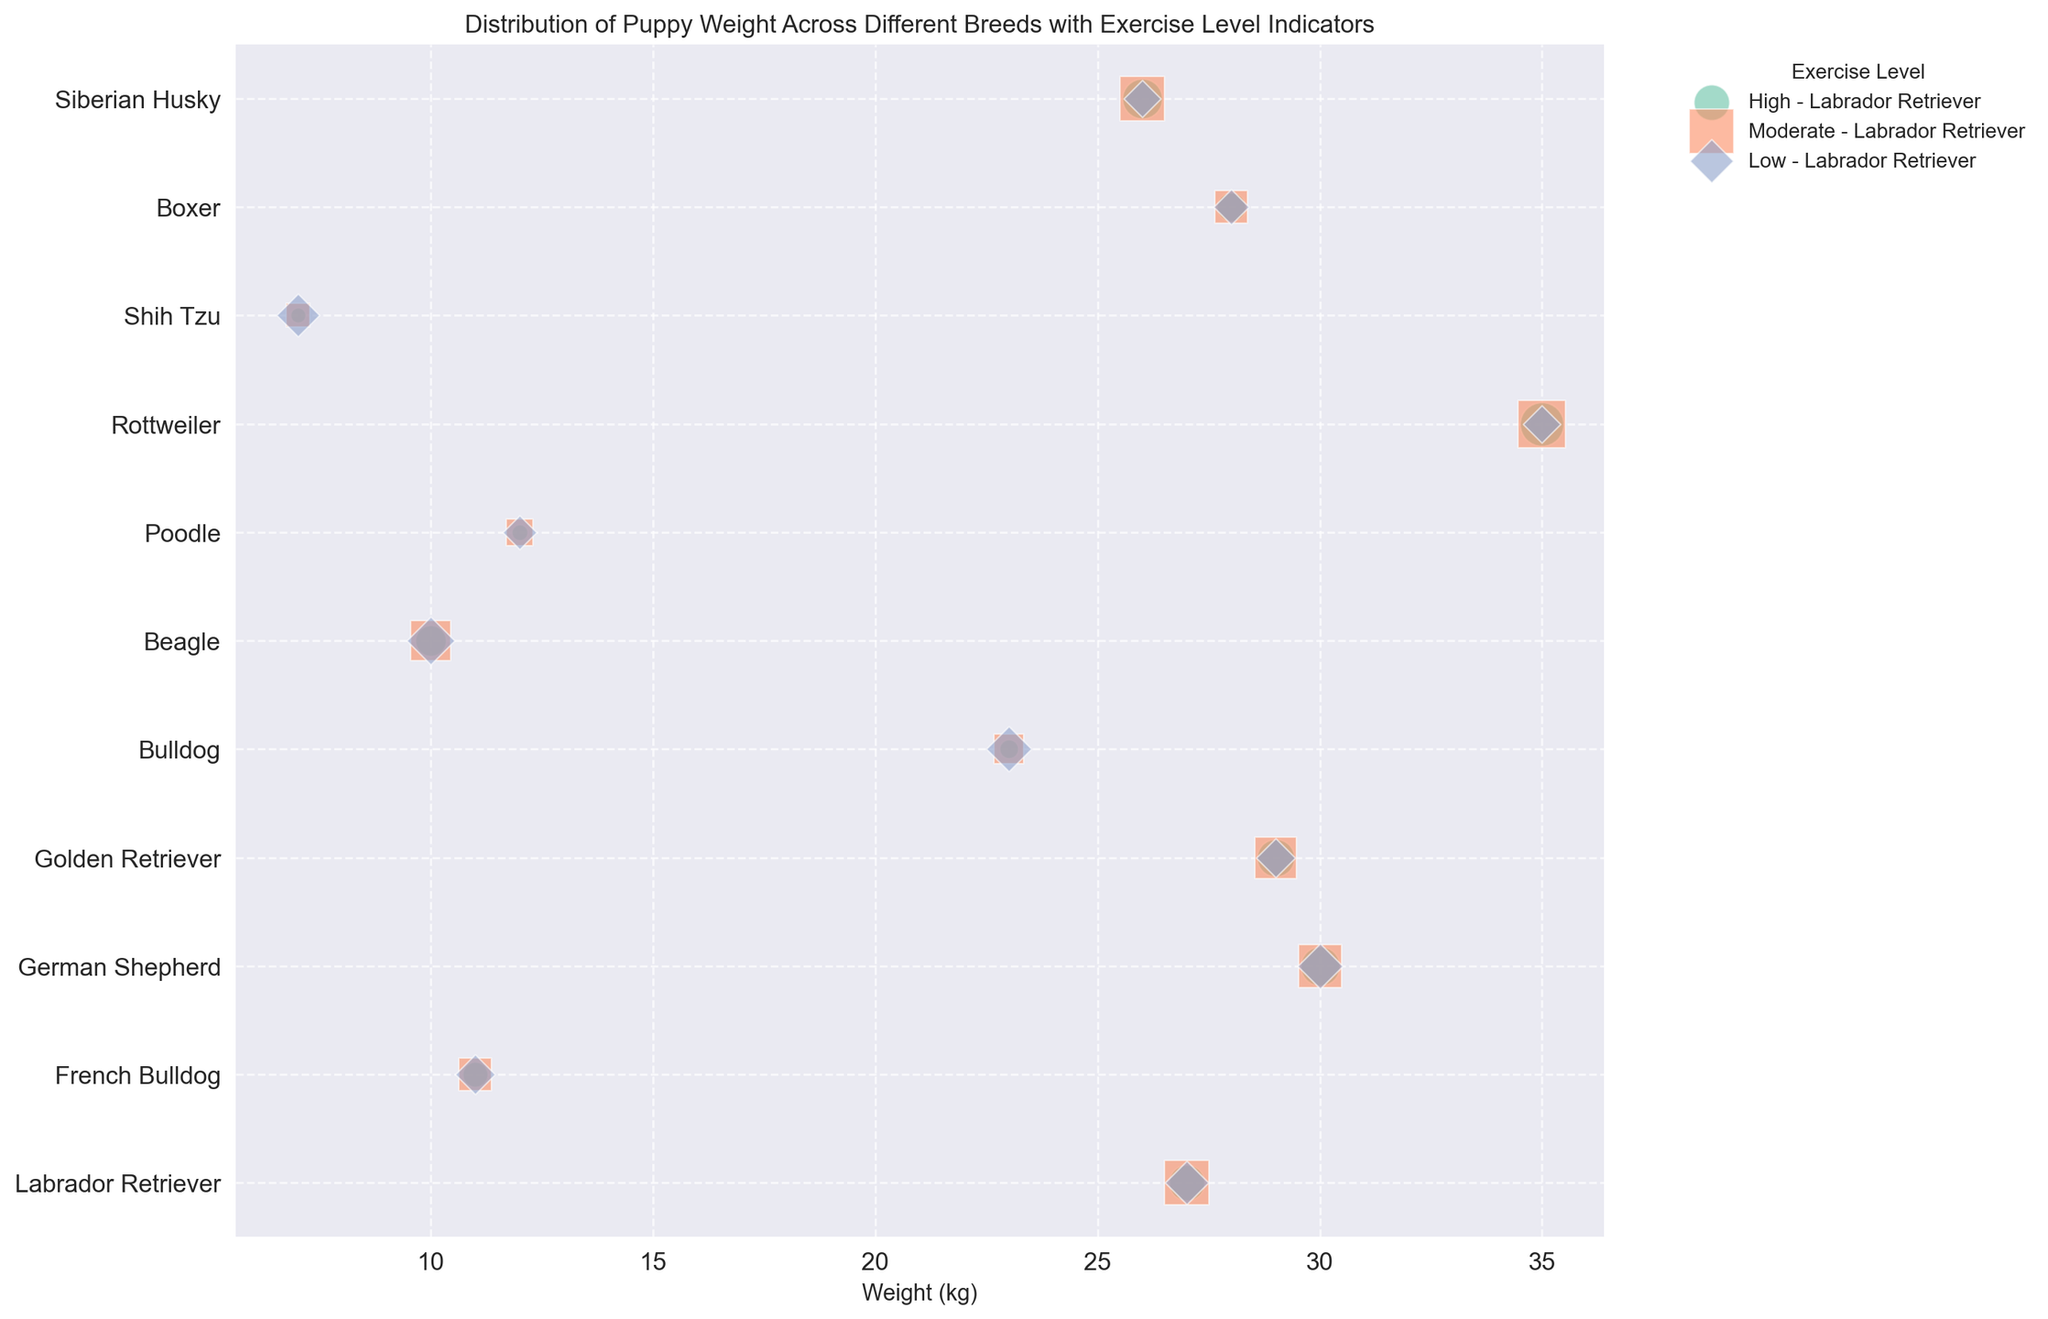What's the most common exercise level for Labradors? By looking at the bubble sizes for Labradors, the largest bubbles correspond to "Moderate" exercise levels. This means the most common exercise level for Labradors is "Moderate".
Answer: Moderate Which breed has the heaviest weight on average? By observing the x-axis, the Rottweiler breed is located furthest to the right with a weight of 35 kg, which indicates it is the heaviest on average.
Answer: Rottweiler Which breed with a weight of 11 kg has the highest number of puppies with a low exercise level? Both French Bulldog and Poodle have bubbles at 11 kg. By checking the bubble sizes for "Low" exercise levels, the French Bulldog has a larger bubble size at 11 kg compared to Poodle.
Answer: French Bulldog For German Shepherds, which exercise level has the least number of puppies? For the German Shepherd breed, the "Low" exercise level has the smallest bubble size compared to "High" and "Moderate" levels.
Answer: Low Compare the number of puppies between High exercise level Beagles and Low exercise level Shih Tzus. Which has more? Beagles with a high exercise level have a bubble size representing 75 puppies, while Shih Tzus with a low exercise level have a bubble size representing 72 puppies. Beagles have more puppies with a high exercise level.
Answer: Beagles What are the exercise levels indicated by the green bubbles? The green bubbles represent the "High" exercise level, as per the color legend in the plot.
Answer: High What is the most common exercise level for Siberian Huskies? Looking at the bubble sizes for Siberian Huskies, the "Moderate" exercise level has the largest bubble, indicating it is the most common exercise level for this breed.
Answer: Moderate Which breed at 23 kg has the highest "Low" exercise level count? The Bulldog breed at 23 kg has the largest bubble size for the "Low" exercise level, signifying the highest count.
Answer: Bulldog Among breeds weighing less than 15 kg, which has the highest count of High exercise level puppies? Beagle weighs 10 kg and has the largest high exercise level bubble size for breeds under 15 kg, with a count of 75 puppies.
Answer: Beagle What color represents the "Moderate" exercise level? According to the legend, the color representing the "Moderate" exercise level is orange.
Answer: Orange 